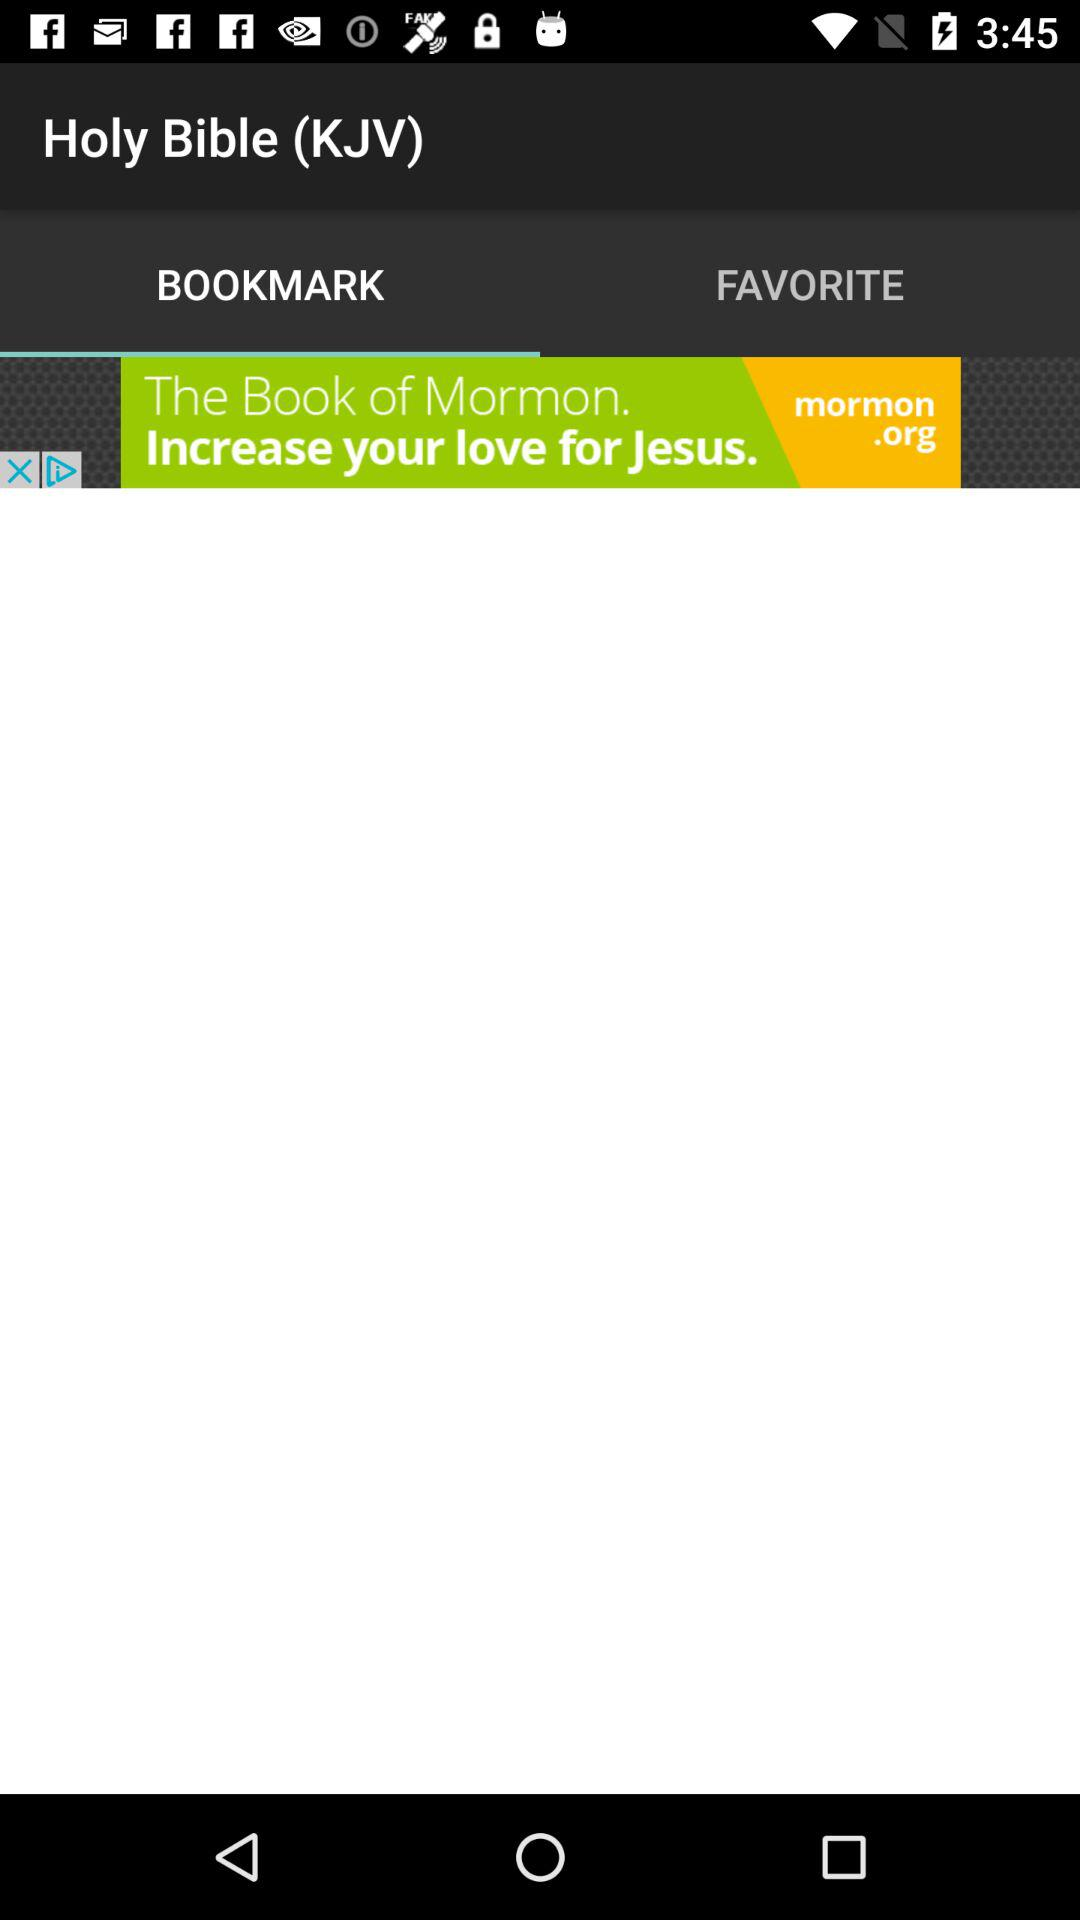Which chapters and verses are in "FAVORITE"?
When the provided information is insufficient, respond with <no answer>. <no answer> 